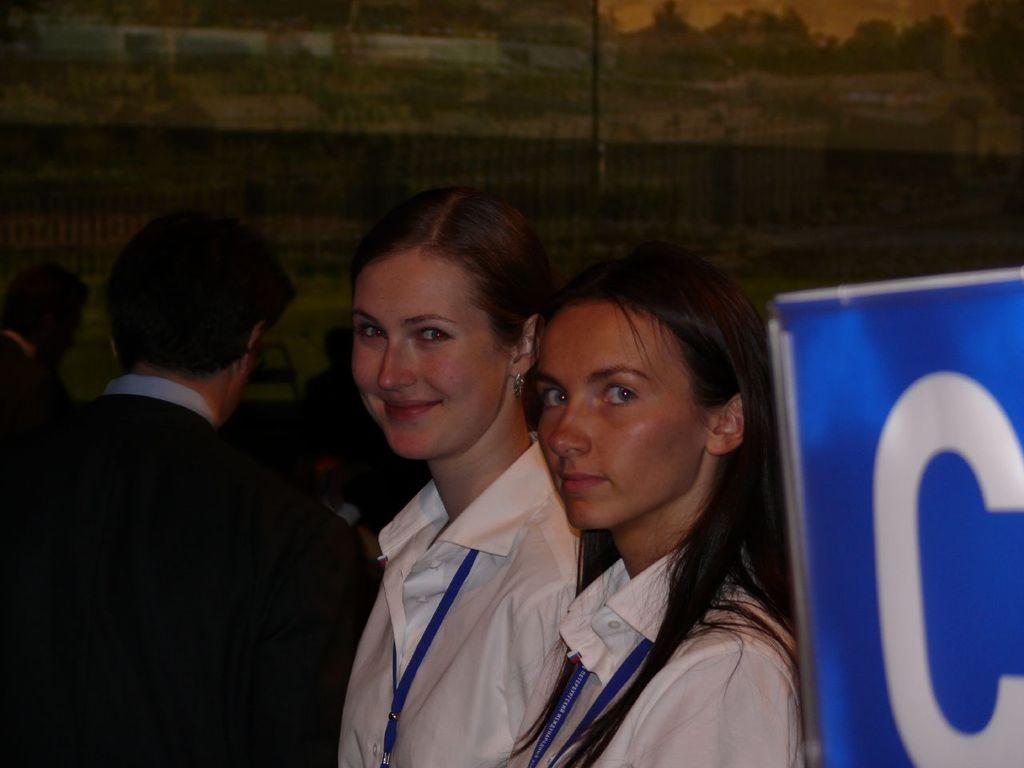Please provide a concise description of this image. In this image I can see two women standing and giving pose for the photo and I can see a man standing behind the women and I can see an unclear background and I can see letter C on a board in the right bottom corner. 